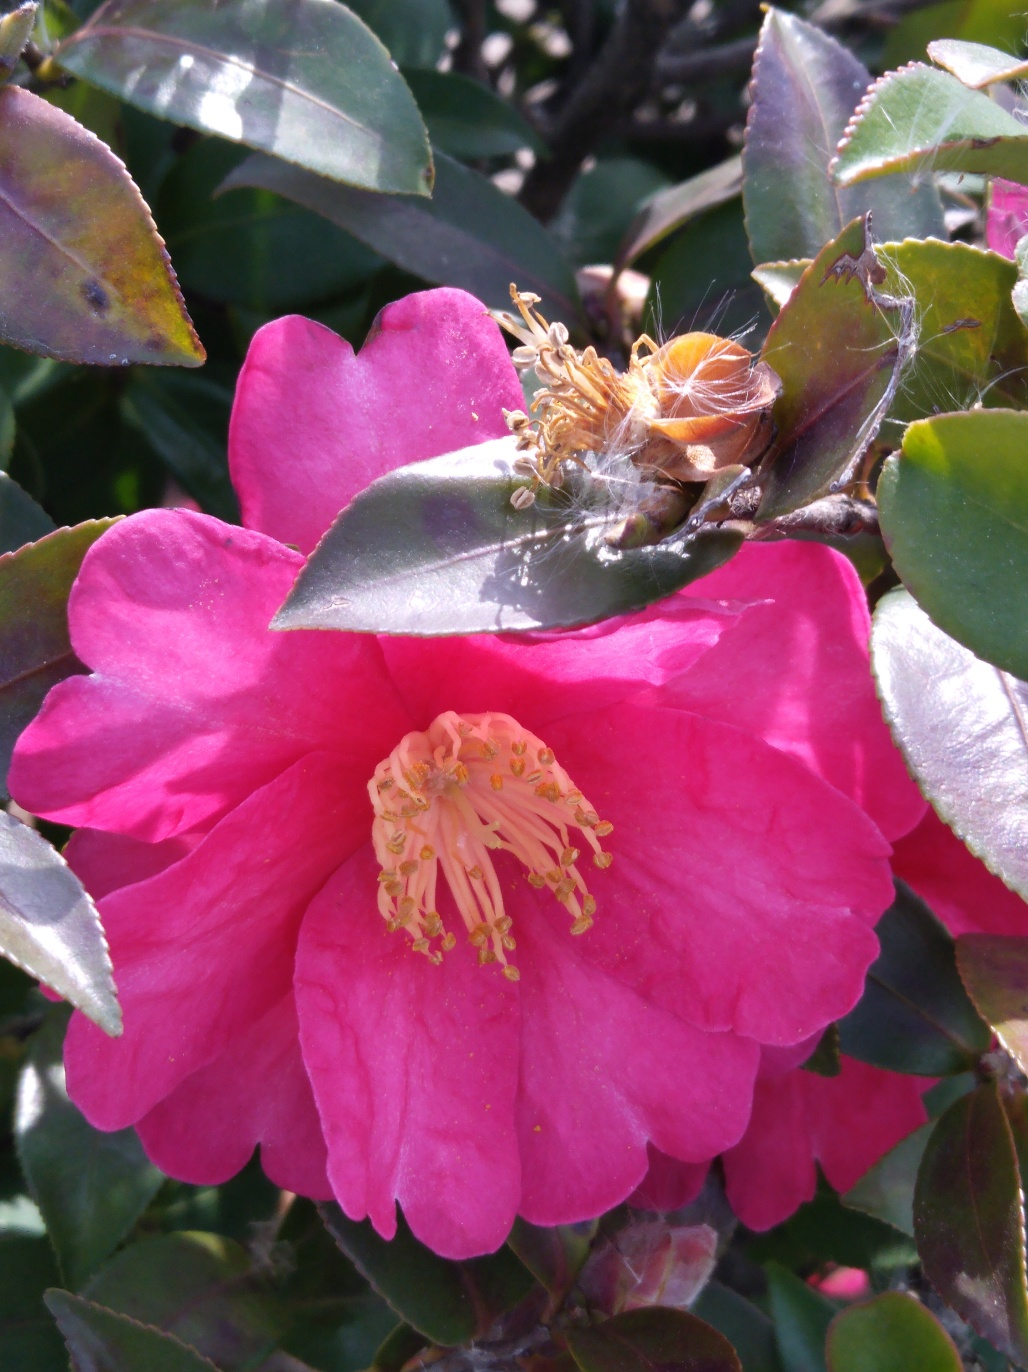Might this type of spider web have a specific function other than catching prey? Yes, beyond trapping prey, spider webs can also provide protection for spiders against predators and harsh weather conditions. They may also play a role in the pollination process, as the sticky web can catch pollen from visiting insects, which can then be transferred to other flowers. 